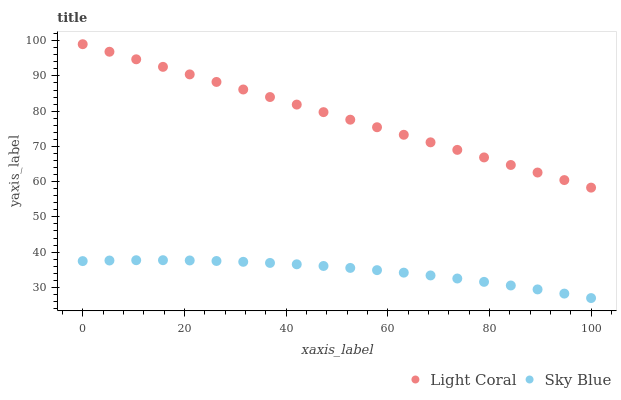Does Sky Blue have the minimum area under the curve?
Answer yes or no. Yes. Does Light Coral have the maximum area under the curve?
Answer yes or no. Yes. Does Sky Blue have the maximum area under the curve?
Answer yes or no. No. Is Light Coral the smoothest?
Answer yes or no. Yes. Is Sky Blue the roughest?
Answer yes or no. Yes. Is Sky Blue the smoothest?
Answer yes or no. No. Does Sky Blue have the lowest value?
Answer yes or no. Yes. Does Light Coral have the highest value?
Answer yes or no. Yes. Does Sky Blue have the highest value?
Answer yes or no. No. Is Sky Blue less than Light Coral?
Answer yes or no. Yes. Is Light Coral greater than Sky Blue?
Answer yes or no. Yes. Does Sky Blue intersect Light Coral?
Answer yes or no. No. 